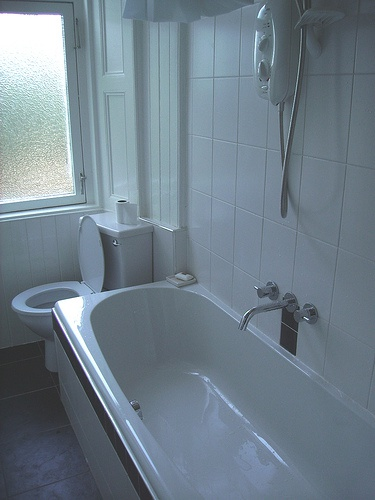Describe the objects in this image and their specific colors. I can see a toilet in gray and darkgray tones in this image. 